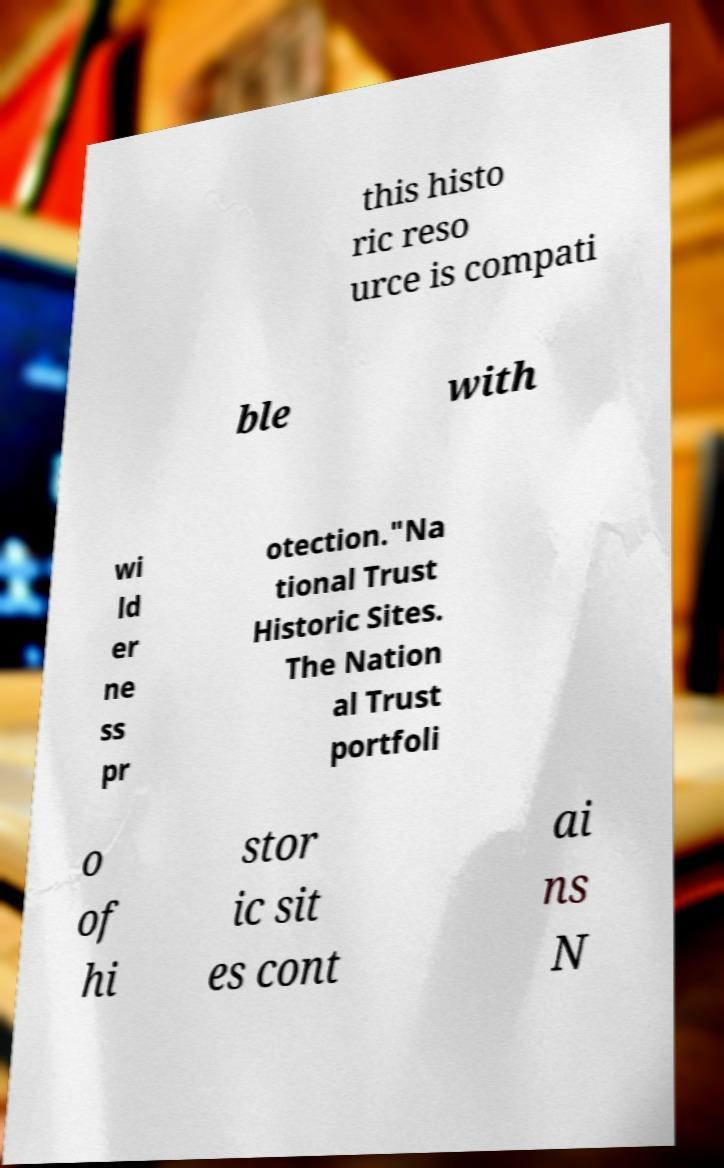There's text embedded in this image that I need extracted. Can you transcribe it verbatim? this histo ric reso urce is compati ble with wi ld er ne ss pr otection."Na tional Trust Historic Sites. The Nation al Trust portfoli o of hi stor ic sit es cont ai ns N 